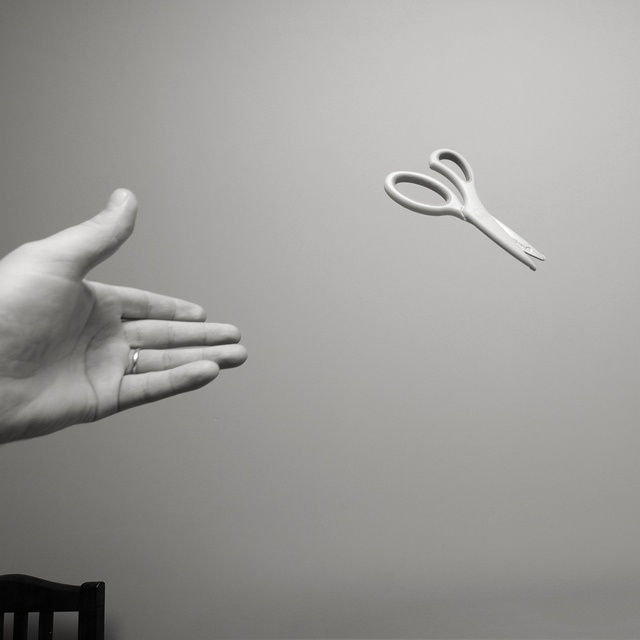Describe the objects in this image and their specific colors. I can see people in gray, darkgray, lightgray, and black tones, chair in gray and black tones, and scissors in gray, lightgray, and darkgray tones in this image. 